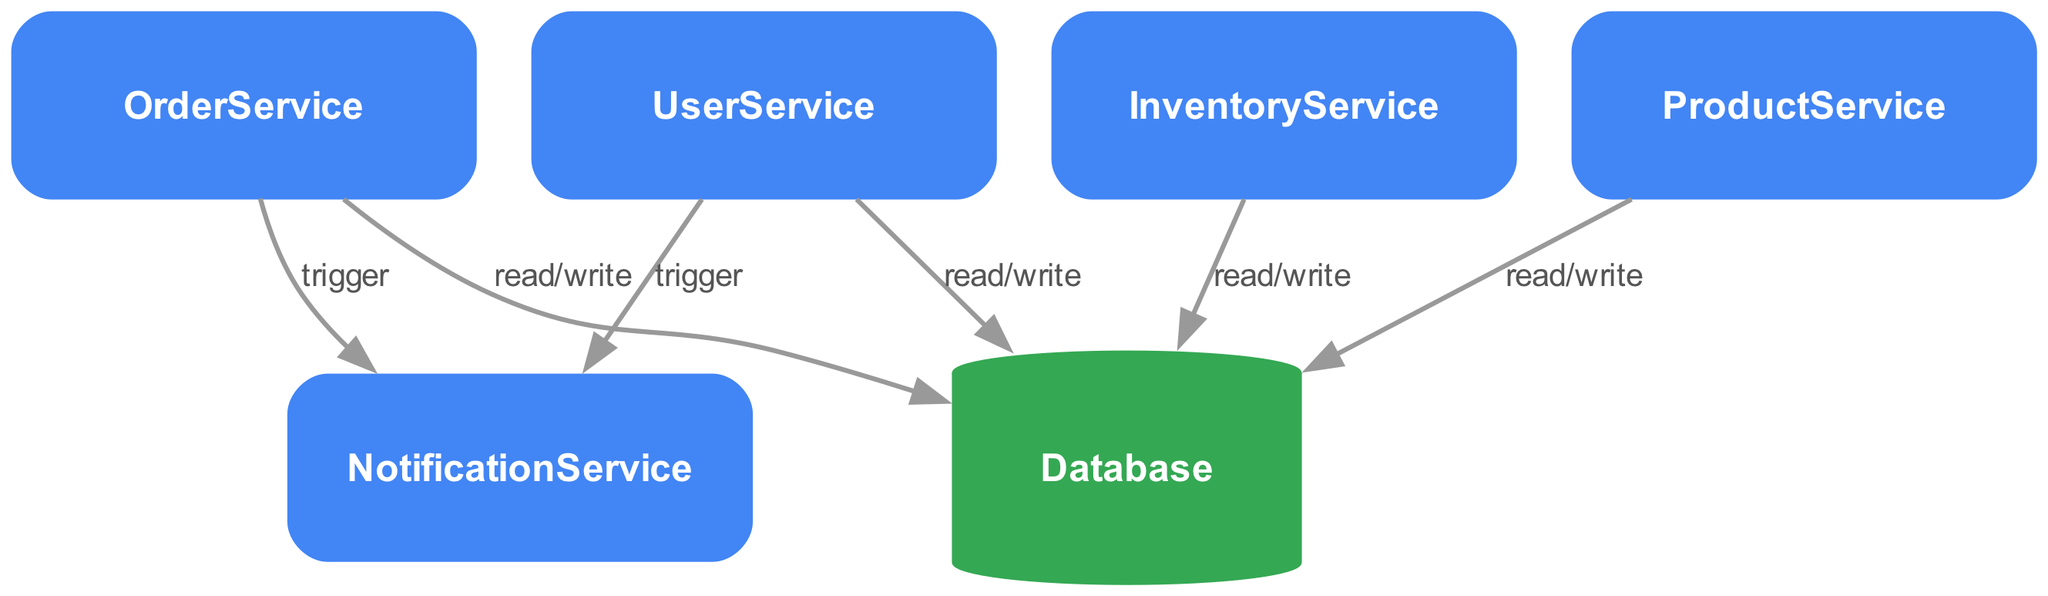What is the total number of services in the diagram? The diagram contains a list of nodes, specifically labeled as services. By counting the entries in the nodes section, we find five services: UserService, ProductService, OrderService, InventoryService, and NotificationService.
Answer: Five Which service handles user profile management? The UserService is explicitly described in the diagram as handling user registration, login, and profile management, as indicated by its description.
Answer: UserService How many edges connect to the Database? The edges in the diagram represent interactions between nodes. The Database is connected to four services: UserService, ProductService, OrderService, and InventoryService. Counting these connections gives us four edges.
Answer: Four Which service triggers notifications upon order processing? The edge from OrderService to NotificationService indicates that the OrderService triggers notifications. This relationship is outlined in the interactions specified in the edges section.
Answer: OrderService What action does OrderService perform on NotificationService? The edge from OrderService to NotificationService specifies the action as "trigger." This action indicates that OrderService initiates a notification process.
Answer: Trigger Is there any service that does not connect to the Database? Upon reviewing the edge connections, both NotificationService and Database are not directly linked. NotificationService does not connect to the Database, indicating it does not perform read/write actions on the database.
Answer: Yes How many services trigger notifications? Analyzing the edges, we note that both UserService and OrderService connect to NotificationService, indicating that two services are responsible for triggering notifications.
Answer: Two What type of graph is this diagram classified as? The diagram is characterized by directed edges that represent the flow of data and actions between nodes. Since the connections have a direction (indicating who triggers whom), it is classified as a directed graph.
Answer: Directed Graph Which service is responsible for managing product catalog? The diagram identifies ProductService specifically for managing the product catalog and performing CRUD operations for products, as indicated by its description in the nodes section.
Answer: ProductService 